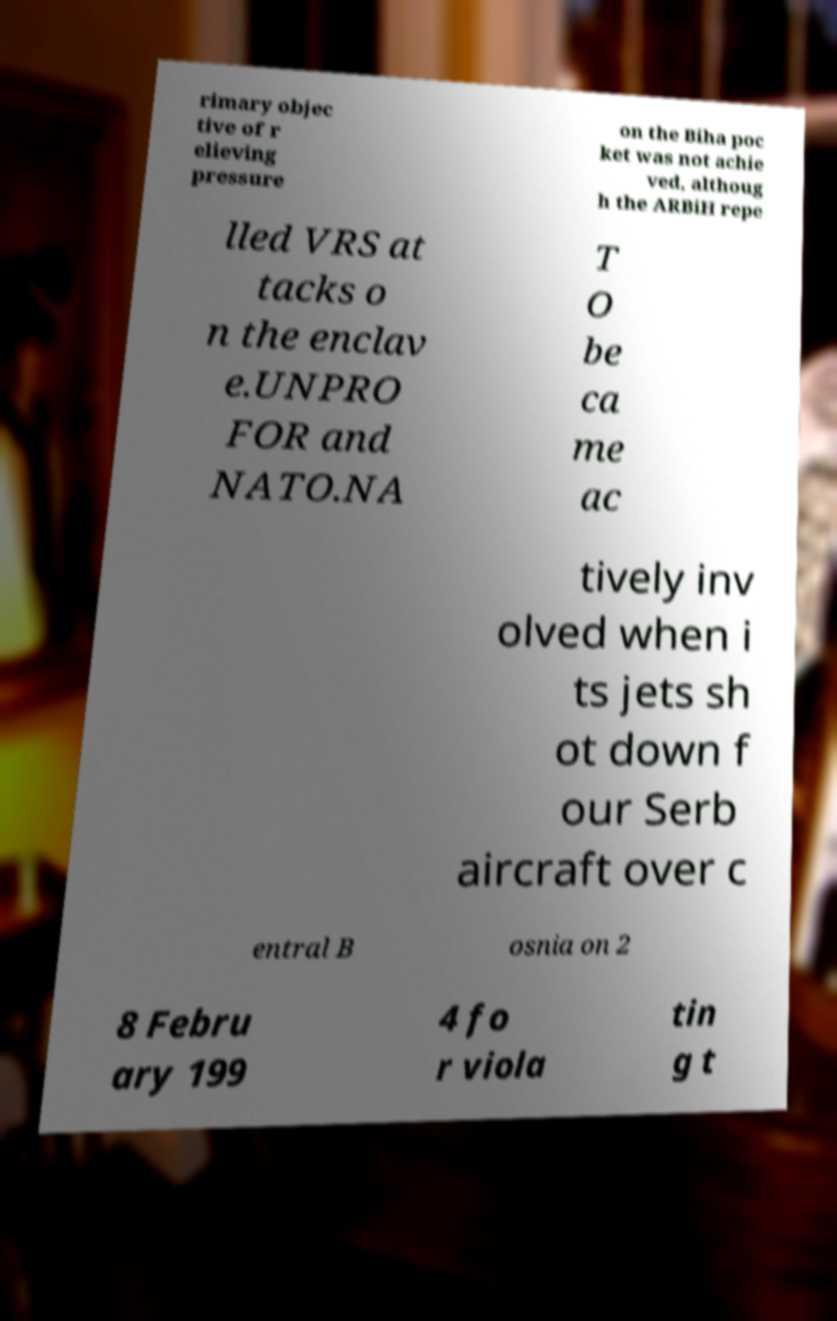I need the written content from this picture converted into text. Can you do that? rimary objec tive of r elieving pressure on the Biha poc ket was not achie ved, althoug h the ARBiH repe lled VRS at tacks o n the enclav e.UNPRO FOR and NATO.NA T O be ca me ac tively inv olved when i ts jets sh ot down f our Serb aircraft over c entral B osnia on 2 8 Febru ary 199 4 fo r viola tin g t 